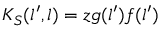<formula> <loc_0><loc_0><loc_500><loc_500>K _ { S } ( l ^ { \prime } , l ) = z g ( l ^ { \prime } ) f ( l ^ { \prime } )</formula> 